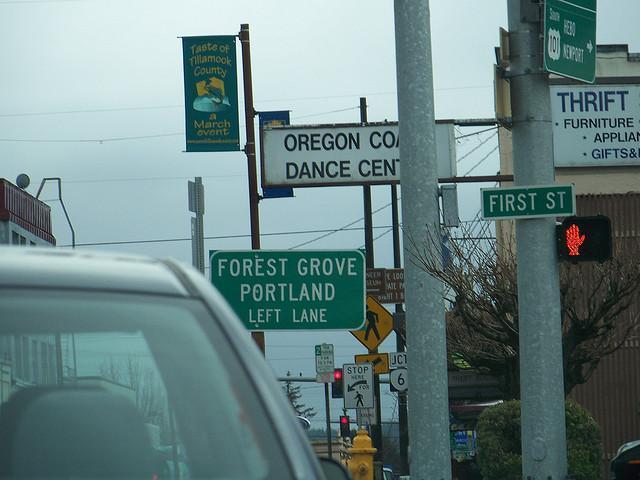How many cars can be seen?
Give a very brief answer. 1. 